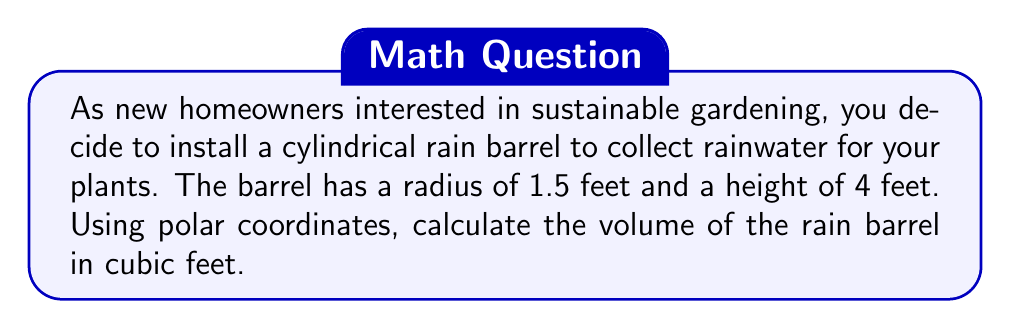Solve this math problem. To calculate the volume of a cylindrical rain barrel using polar coordinates, we'll follow these steps:

1) In polar coordinates, a cylinder is represented by:
   $$ r = R, \quad 0 \leq \theta \leq 2\pi, \quad 0 \leq z \leq h $$
   where $R$ is the radius and $h$ is the height.

2) The volume formula in polar coordinates is:
   $$ V = \int_0^h \int_0^{2\pi} \int_0^R r \, dr \, d\theta \, dz $$

3) Let's substitute the given values: $R = 1.5$ feet, $h = 4$ feet

4) Now, let's solve the triple integral:

   $$ V = \int_0^4 \int_0^{2\pi} \int_0^{1.5} r \, dr \, d\theta \, dz $$

5) First, integrate with respect to $r$:
   $$ V = \int_0^4 \int_0^{2\pi} [\frac{r^2}{2}]_0^{1.5} \, d\theta \, dz = \int_0^4 \int_0^{2\pi} \frac{(1.5)^2}{2} \, d\theta \, dz $$

6) Now, integrate with respect to $\theta$:
   $$ V = \int_0^4 [\frac{(1.5)^2}{2} \theta]_0^{2\pi} \, dz = \int_0^4 \frac{(1.5)^2}{2} \cdot 2\pi \, dz $$

7) Finally, integrate with respect to $z$:
   $$ V = [\frac{(1.5)^2}{2} \cdot 2\pi \cdot z]_0^4 = \frac{(1.5)^2}{2} \cdot 2\pi \cdot 4 $$

8) Simplify:
   $$ V = \frac{9}{4} \cdot 2\pi \cdot 4 = 9\pi $$

Therefore, the volume of the rain barrel is $9\pi$ cubic feet.
Answer: $9\pi$ cubic feet (approximately 28.27 cubic feet) 